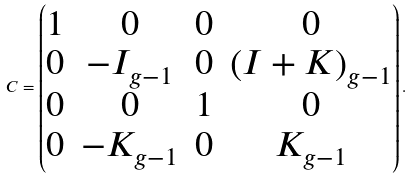Convert formula to latex. <formula><loc_0><loc_0><loc_500><loc_500>C = \begin{pmatrix} 1 & 0 & 0 & 0 \\ 0 & - I _ { g - 1 } & 0 & ( I + K ) _ { g - 1 } \\ 0 & 0 & 1 & 0 \\ 0 & - K _ { g - 1 } & 0 & K _ { g - 1 } \end{pmatrix} .</formula> 